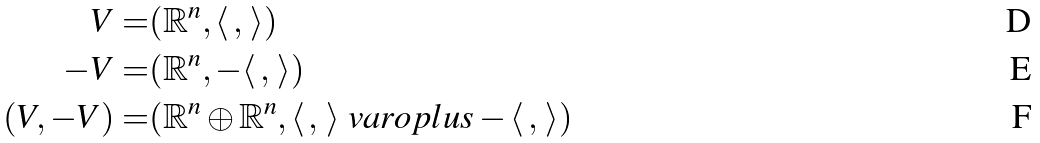Convert formula to latex. <formula><loc_0><loc_0><loc_500><loc_500>V = & ( \mathbb { R } ^ { n } , \langle \, , \, \rangle ) \\ - V = & ( \mathbb { R } ^ { n } , - \langle \, , \, \rangle ) \\ ( V , - V ) = & ( \mathbb { R } ^ { n } \oplus \mathbb { R } ^ { n } , \langle \, , \, \rangle \ v a r o p l u s - \langle \, , \, \rangle )</formula> 